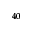Convert formula to latex. <formula><loc_0><loc_0><loc_500><loc_500>^ { 4 0 }</formula> 